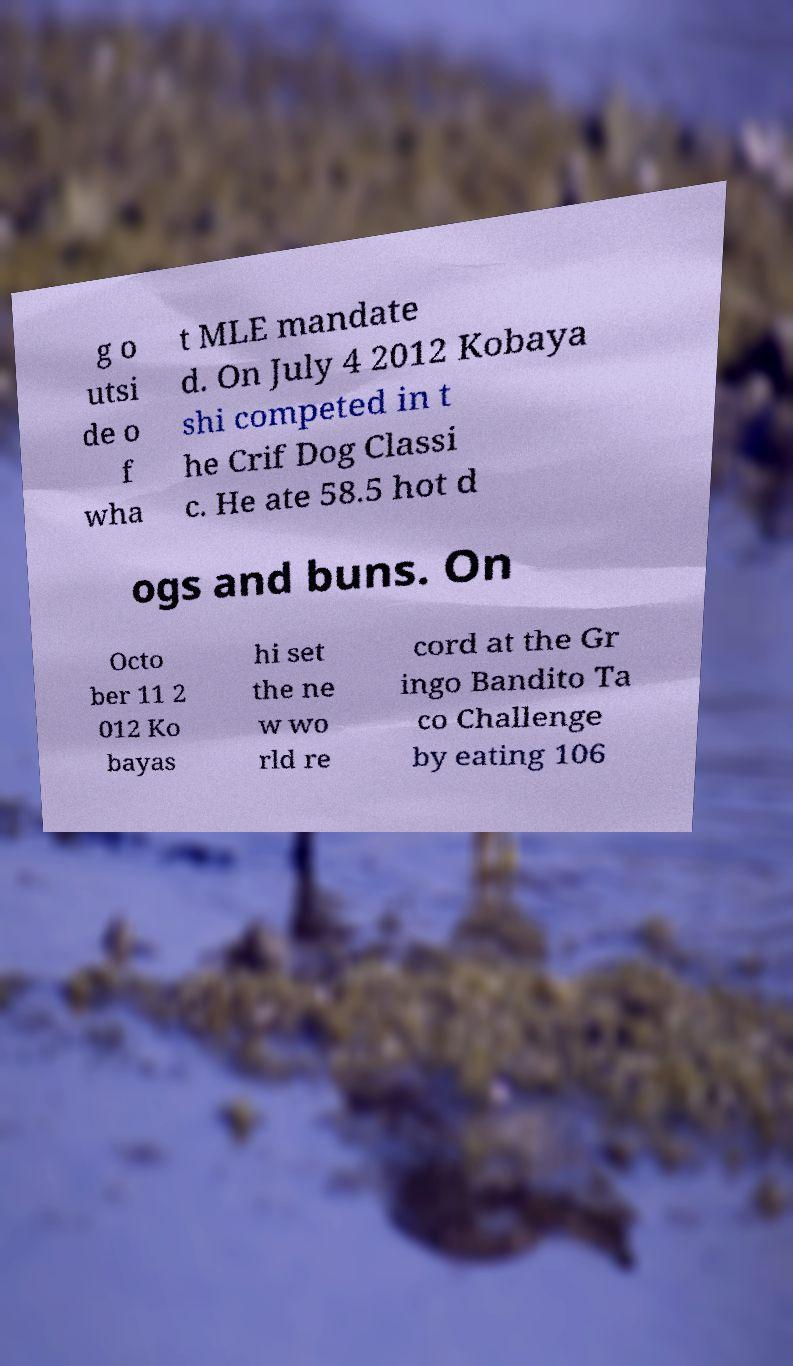Can you accurately transcribe the text from the provided image for me? g o utsi de o f wha t MLE mandate d. On July 4 2012 Kobaya shi competed in t he Crif Dog Classi c. He ate 58.5 hot d ogs and buns. On Octo ber 11 2 012 Ko bayas hi set the ne w wo rld re cord at the Gr ingo Bandito Ta co Challenge by eating 106 